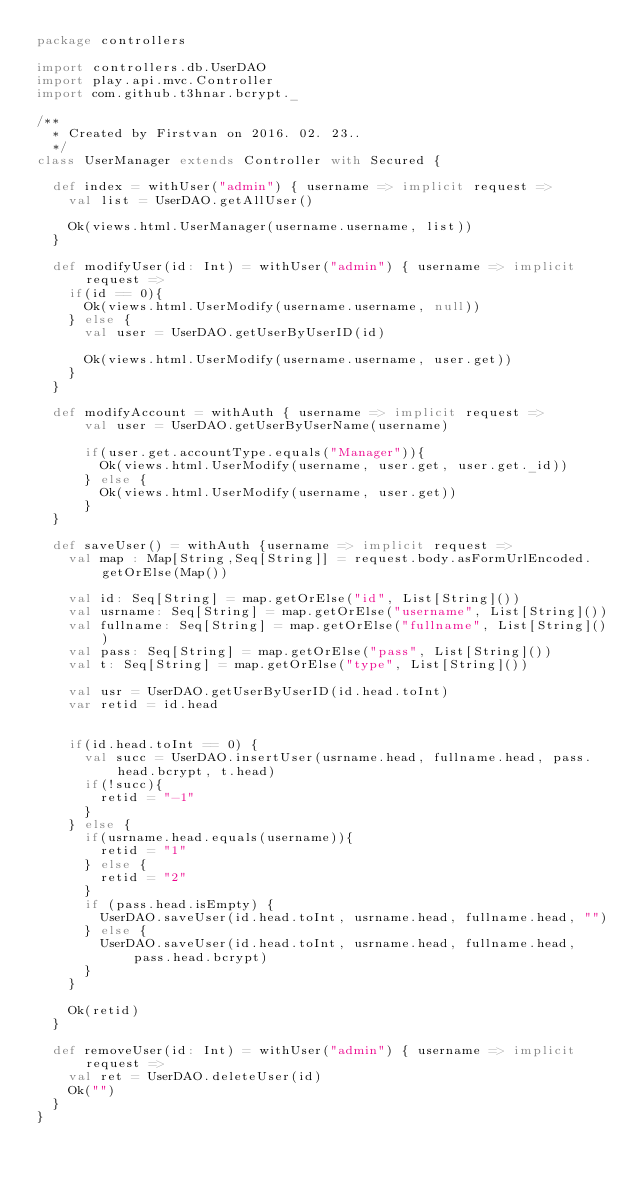<code> <loc_0><loc_0><loc_500><loc_500><_Scala_>package controllers

import controllers.db.UserDAO
import play.api.mvc.Controller
import com.github.t3hnar.bcrypt._

/**
  * Created by Firstvan on 2016. 02. 23..
  */
class UserManager extends Controller with Secured {

  def index = withUser("admin") { username => implicit request =>
    val list = UserDAO.getAllUser()

    Ok(views.html.UserManager(username.username, list))
  }

  def modifyUser(id: Int) = withUser("admin") { username => implicit request =>
    if(id == 0){
      Ok(views.html.UserModify(username.username, null))
    } else {
      val user = UserDAO.getUserByUserID(id)

      Ok(views.html.UserModify(username.username, user.get))
    }
  }

  def modifyAccount = withAuth { username => implicit request =>
      val user = UserDAO.getUserByUserName(username)

      if(user.get.accountType.equals("Manager")){
        Ok(views.html.UserModify(username, user.get, user.get._id))
      } else {
        Ok(views.html.UserModify(username, user.get))
      }
  }

  def saveUser() = withAuth {username => implicit request =>
    val map : Map[String,Seq[String]] = request.body.asFormUrlEncoded.getOrElse(Map())

    val id: Seq[String] = map.getOrElse("id", List[String]())
    val usrname: Seq[String] = map.getOrElse("username", List[String]())
    val fullname: Seq[String] = map.getOrElse("fullname", List[String]())
    val pass: Seq[String] = map.getOrElse("pass", List[String]())
    val t: Seq[String] = map.getOrElse("type", List[String]())

    val usr = UserDAO.getUserByUserID(id.head.toInt)
    var retid = id.head


    if(id.head.toInt == 0) {
      val succ = UserDAO.insertUser(usrname.head, fullname.head, pass.head.bcrypt, t.head)
      if(!succ){
        retid = "-1"
      }
    } else {
      if(usrname.head.equals(username)){
        retid = "1"
      } else {
        retid = "2"
      }
      if (pass.head.isEmpty) {
        UserDAO.saveUser(id.head.toInt, usrname.head, fullname.head, "")
      } else {
        UserDAO.saveUser(id.head.toInt, usrname.head, fullname.head, pass.head.bcrypt)
      }
    }

    Ok(retid)
  }

  def removeUser(id: Int) = withUser("admin") { username => implicit request =>
    val ret = UserDAO.deleteUser(id)
    Ok("")
  }
}
</code> 